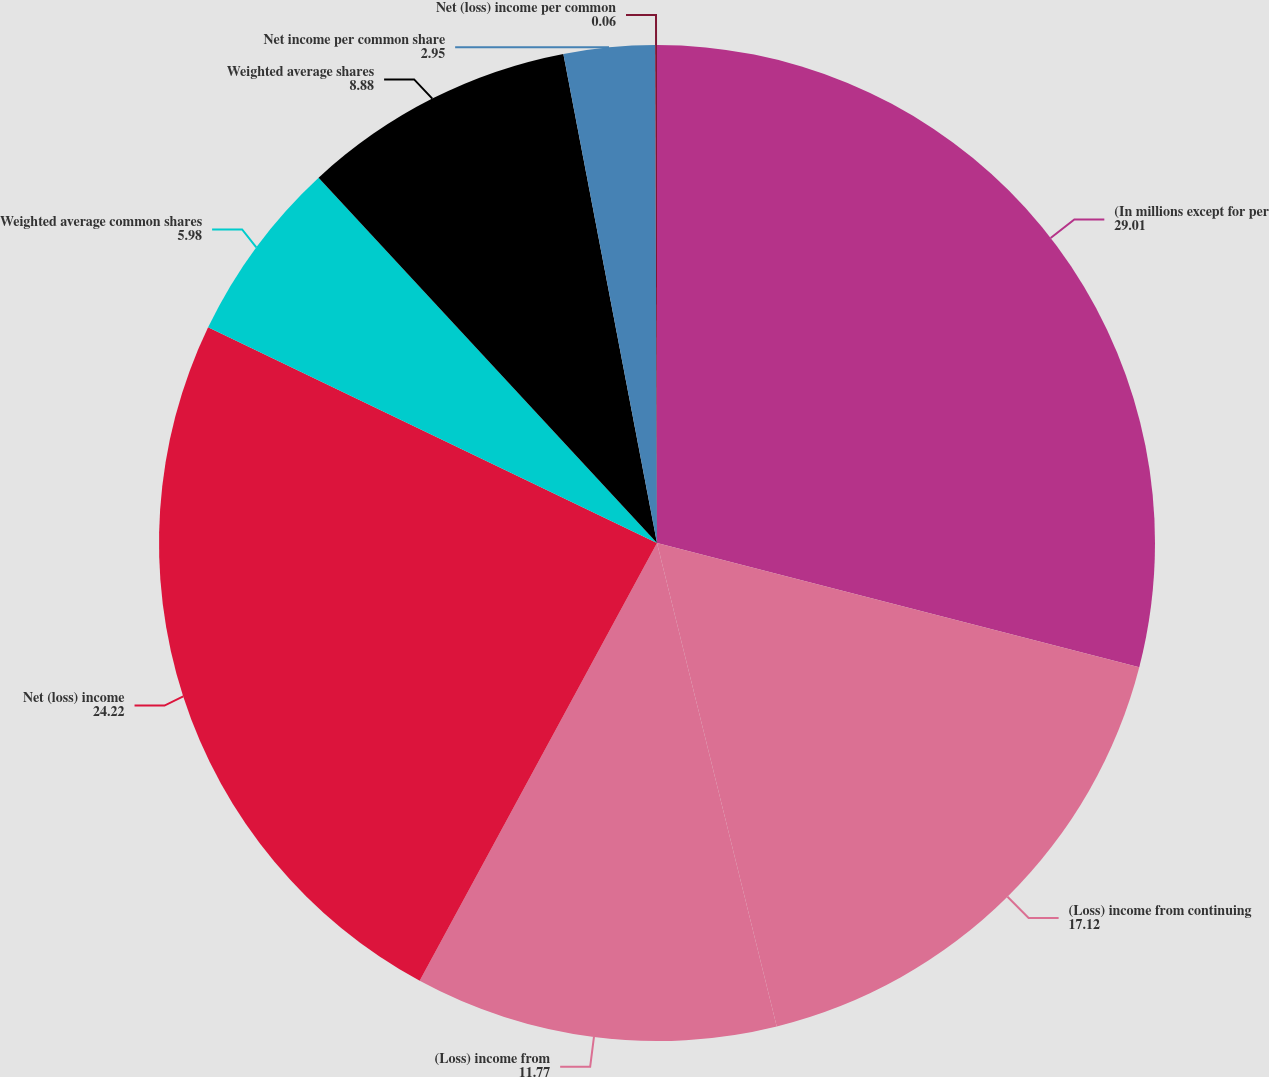Convert chart. <chart><loc_0><loc_0><loc_500><loc_500><pie_chart><fcel>(In millions except for per<fcel>(Loss) income from continuing<fcel>(Loss) income from<fcel>Net (loss) income<fcel>Weighted average common shares<fcel>Weighted average shares<fcel>Net income per common share<fcel>Net (loss) income per common<nl><fcel>29.01%<fcel>17.12%<fcel>11.77%<fcel>24.22%<fcel>5.98%<fcel>8.88%<fcel>2.95%<fcel>0.06%<nl></chart> 